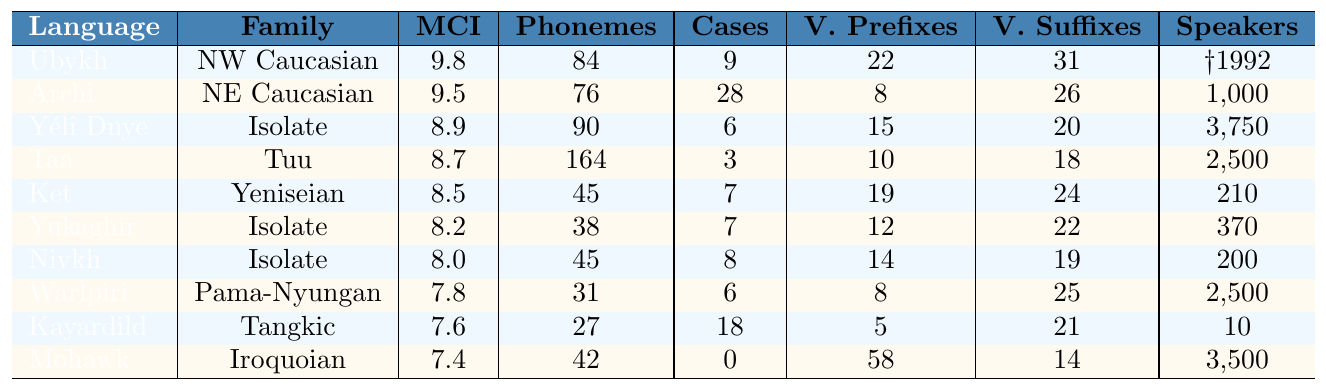What is the morphological complexity index of Ubykh? Ubykh's row in the table specifies a morphological complexity index of 9.8.
Answer: 9.8 How many case markers does Archi have? The table shows that Archi has 28 case markers listed in its row.
Answer: 28 Which language has the highest phoneme count? By comparing the phoneme counts across the languages, Taa has the highest count at 164.
Answer: Taa Is there any language with zero case markers? By examining the table, Mohawk is the only language listed with zero case markers.
Answer: Yes What is the average morphological complexity index of the languages listed? To find the average, add the indices (9.8 + 9.5 + 8.9 + 8.7 + 8.5 + 8.2 + 8.0 + 7.8 + 7.6 + 7.4 = 85.4), then divide by the number of languages (10), resulting in an average of 8.54.
Answer: 8.54 Which language has the most verb prefixes, and how many does it have? The table indicates that Mohawk has the most verb prefixes, with a total of 58.
Answer: Mohawk, 58 Compare the morphological complexity index of Ubykh and Yélî Dnye. Which is higher? Ubykh's MCI is 9.8, while Yélî Dnye's MCI is 8.9. Since 9.8 is greater than 8.9, Ubykh has a higher index.
Answer: Ubykh How many languages have a morphological complexity index above 8.5? Looking at the table, Ubykh, Archi, and Yélî Dnye have MCIs above 8.5, totaling 3 languages.
Answer: 3 What is the phoneme difference between Taa and Ket? Taa has 164 phonemes while Ket has 45. The difference is calculated as 164 - 45 = 119.
Answer: 119 Does any language have more verb suffixes than verb prefixes? By analyzing the table, Kayardild has 21 verb suffixes and 5 verb prefixes, showing it has more suffixes than prefixes.
Answer: Yes Which language from the table has the least number of speakers? The row for Kayardild indicates it has only 10 speakers, which is the least among the languages listed.
Answer: Kayardild, 10 